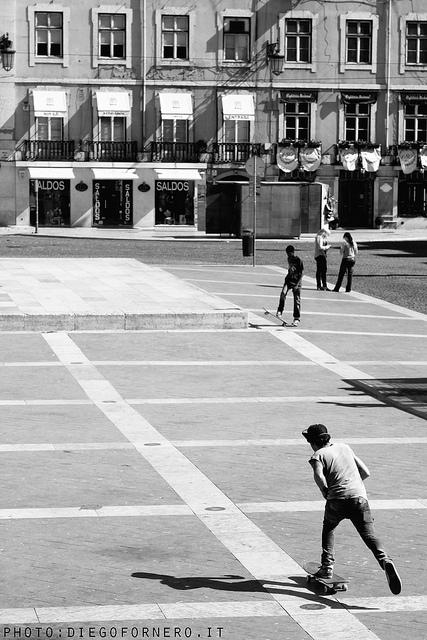Why is the boy kicking his leg back? Please explain your reasoning. for speed. He is pushing him self to get going on the skateboard. 